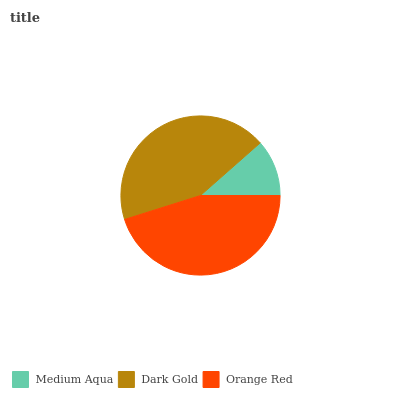Is Medium Aqua the minimum?
Answer yes or no. Yes. Is Orange Red the maximum?
Answer yes or no. Yes. Is Dark Gold the minimum?
Answer yes or no. No. Is Dark Gold the maximum?
Answer yes or no. No. Is Dark Gold greater than Medium Aqua?
Answer yes or no. Yes. Is Medium Aqua less than Dark Gold?
Answer yes or no. Yes. Is Medium Aqua greater than Dark Gold?
Answer yes or no. No. Is Dark Gold less than Medium Aqua?
Answer yes or no. No. Is Dark Gold the high median?
Answer yes or no. Yes. Is Dark Gold the low median?
Answer yes or no. Yes. Is Medium Aqua the high median?
Answer yes or no. No. Is Orange Red the low median?
Answer yes or no. No. 